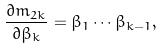<formula> <loc_0><loc_0><loc_500><loc_500>\frac { \partial m _ { 2 k } } { \partial \beta _ { k } } = \beta _ { 1 } \cdots \beta _ { k - 1 } ,</formula> 